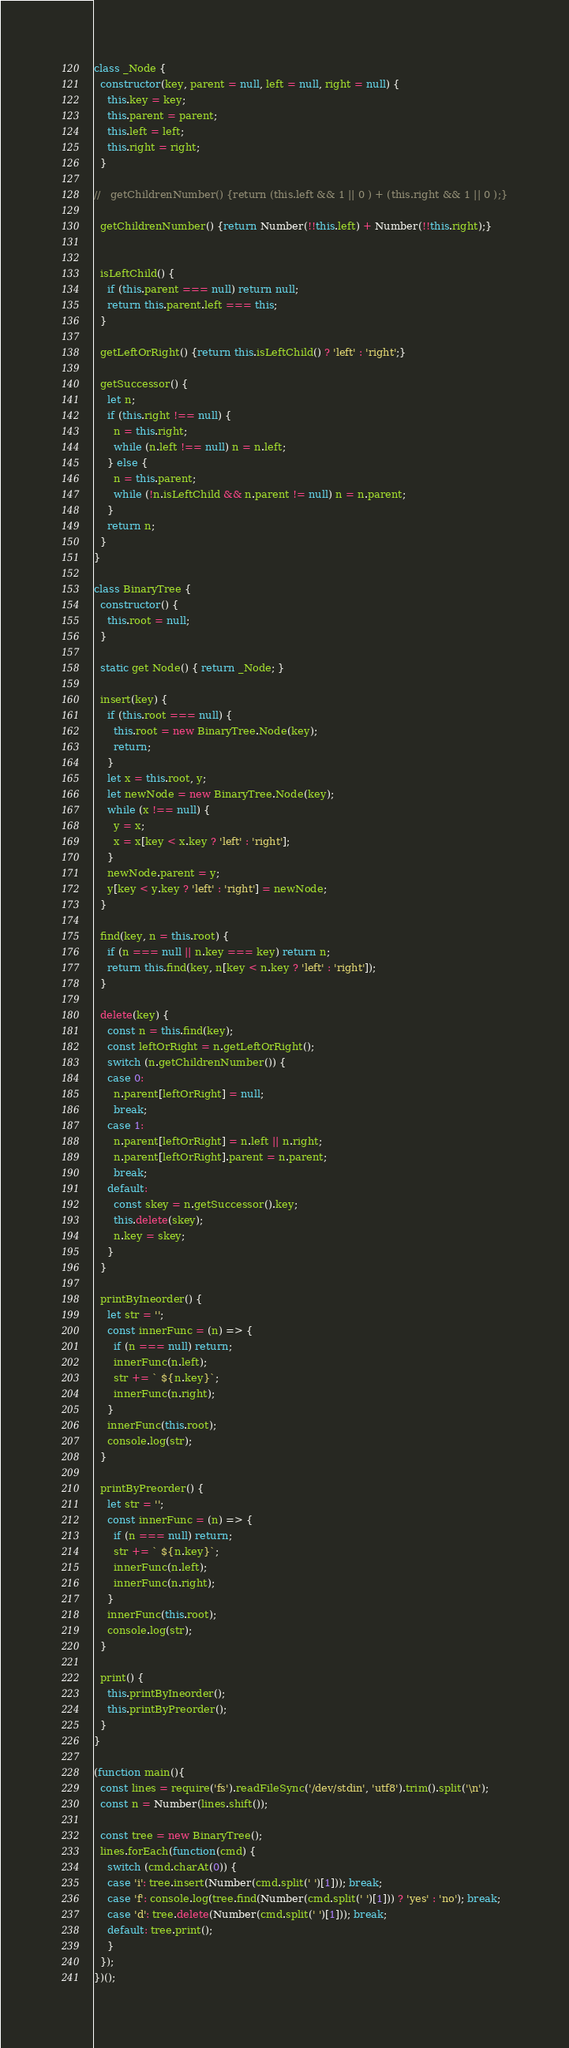<code> <loc_0><loc_0><loc_500><loc_500><_JavaScript_>class _Node {
  constructor(key, parent = null, left = null, right = null) {
    this.key = key;
    this.parent = parent;
    this.left = left;
    this.right = right;
  }

//   getChildrenNumber() {return (this.left && 1 || 0 ) + (this.right && 1 || 0 );}

  getChildrenNumber() {return Number(!!this.left) + Number(!!this.right);}


  isLeftChild() {
    if (this.parent === null) return null;
    return this.parent.left === this;
  }

  getLeftOrRight() {return this.isLeftChild() ? 'left' : 'right';}

  getSuccessor() {
    let n;
    if (this.right !== null) {
      n = this.right;
      while (n.left !== null) n = n.left;
    } else {
      n = this.parent;
      while (!n.isLeftChild && n.parent != null) n = n.parent;
    }
    return n;
  }
}

class BinaryTree {
  constructor() {
    this.root = null;
  }

  static get Node() { return _Node; }

  insert(key) {
    if (this.root === null) {
      this.root = new BinaryTree.Node(key);
      return;
    }
    let x = this.root, y;
    let newNode = new BinaryTree.Node(key);
    while (x !== null) {
      y = x;
      x = x[key < x.key ? 'left' : 'right'];
    }
    newNode.parent = y;
    y[key < y.key ? 'left' : 'right'] = newNode;
  }

  find(key, n = this.root) {
    if (n === null || n.key === key) return n;
    return this.find(key, n[key < n.key ? 'left' : 'right']);
  }

  delete(key) {
    const n = this.find(key);
    const leftOrRight = n.getLeftOrRight();
    switch (n.getChildrenNumber()) {
    case 0:
      n.parent[leftOrRight] = null;
      break;
    case 1:
      n.parent[leftOrRight] = n.left || n.right;
      n.parent[leftOrRight].parent = n.parent;
      break;
    default:
      const skey = n.getSuccessor().key;
      this.delete(skey);
      n.key = skey;
    }
  }

  printByIneorder() {
    let str = '';
    const innerFunc = (n) => {
      if (n === null) return;
      innerFunc(n.left);
      str += ` ${n.key}`;
      innerFunc(n.right);
    }
    innerFunc(this.root);
    console.log(str);
  }

  printByPreorder() {
    let str = '';
    const innerFunc = (n) => {
      if (n === null) return;
      str += ` ${n.key}`;
      innerFunc(n.left);
      innerFunc(n.right);
    }
    innerFunc(this.root);
    console.log(str);
  }

  print() {
    this.printByIneorder();
    this.printByPreorder();
  }
}

(function main(){
  const lines = require('fs').readFileSync('/dev/stdin', 'utf8').trim().split('\n');
  const n = Number(lines.shift());

  const tree = new BinaryTree();
  lines.forEach(function(cmd) {
    switch (cmd.charAt(0)) {
    case 'i': tree.insert(Number(cmd.split(' ')[1])); break;
    case 'f': console.log(tree.find(Number(cmd.split(' ')[1])) ? 'yes' : 'no'); break;
    case 'd': tree.delete(Number(cmd.split(' ')[1])); break;
    default: tree.print();
    }
  });
})();

</code> 